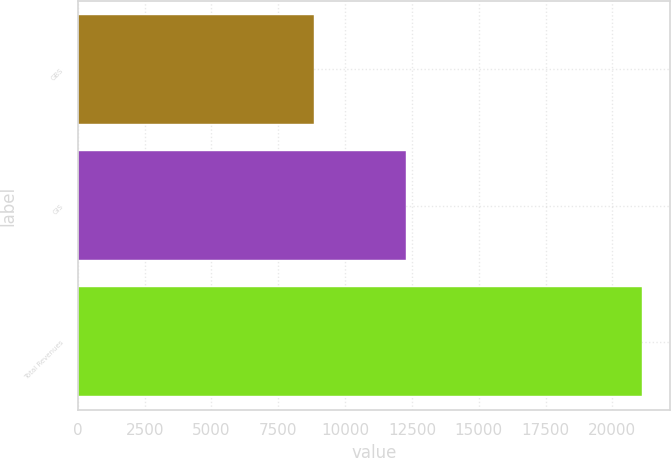Convert chart. <chart><loc_0><loc_0><loc_500><loc_500><bar_chart><fcel>GBS<fcel>GIS<fcel>Total Revenues<nl><fcel>8823<fcel>12282<fcel>21105<nl></chart> 